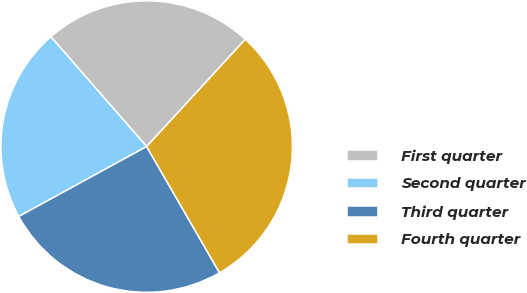Convert chart to OTSL. <chart><loc_0><loc_0><loc_500><loc_500><pie_chart><fcel>First quarter<fcel>Second quarter<fcel>Third quarter<fcel>Fourth quarter<nl><fcel>23.25%<fcel>21.55%<fcel>25.37%<fcel>29.83%<nl></chart> 